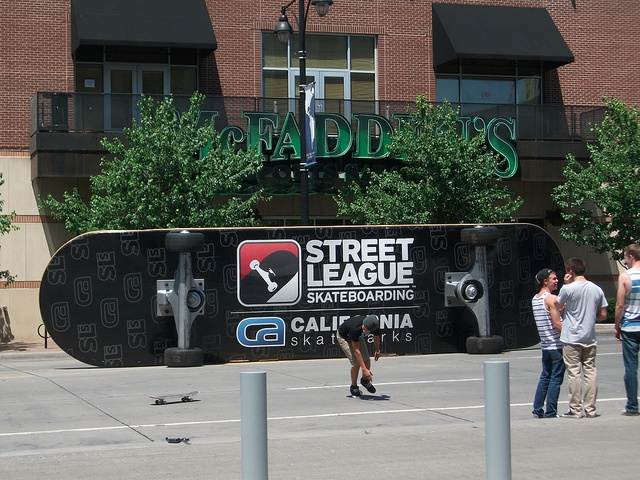Describe the objects in this image and their specific colors. I can see skateboard in gray, black, lightgray, and darkgray tones, people in gray, darkgray, lightgray, and black tones, people in gray, black, navy, blue, and lightgray tones, people in gray, black, darkblue, and lightgray tones, and people in gray, black, maroon, and darkgray tones in this image. 